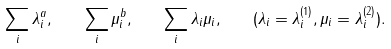Convert formula to latex. <formula><loc_0><loc_0><loc_500><loc_500>\sum _ { i } \lambda _ { i } ^ { a } , \quad \sum _ { i } \mu _ { i } ^ { b } , \quad \sum _ { i } \lambda _ { i } \mu _ { i } , \quad ( \lambda _ { i } = \lambda _ { i } ^ { ( 1 ) } , \mu _ { i } = \lambda _ { i } ^ { ( 2 ) } ) .</formula> 